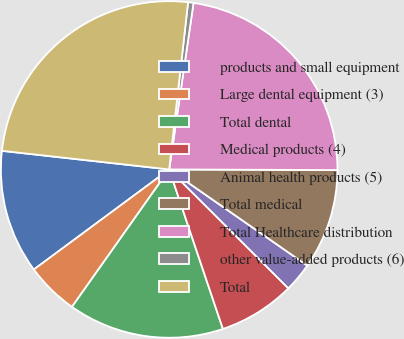Convert chart to OTSL. <chart><loc_0><loc_0><loc_500><loc_500><pie_chart><fcel>products and small equipment<fcel>Large dental equipment (3)<fcel>Total dental<fcel>Medical products (4)<fcel>Animal health products (5)<fcel>Total medical<fcel>Total Healthcare distribution<fcel>other value-added products (6)<fcel>Total<nl><fcel>11.9%<fcel>5.07%<fcel>14.97%<fcel>7.35%<fcel>2.8%<fcel>9.62%<fcel>22.75%<fcel>0.52%<fcel>25.03%<nl></chart> 